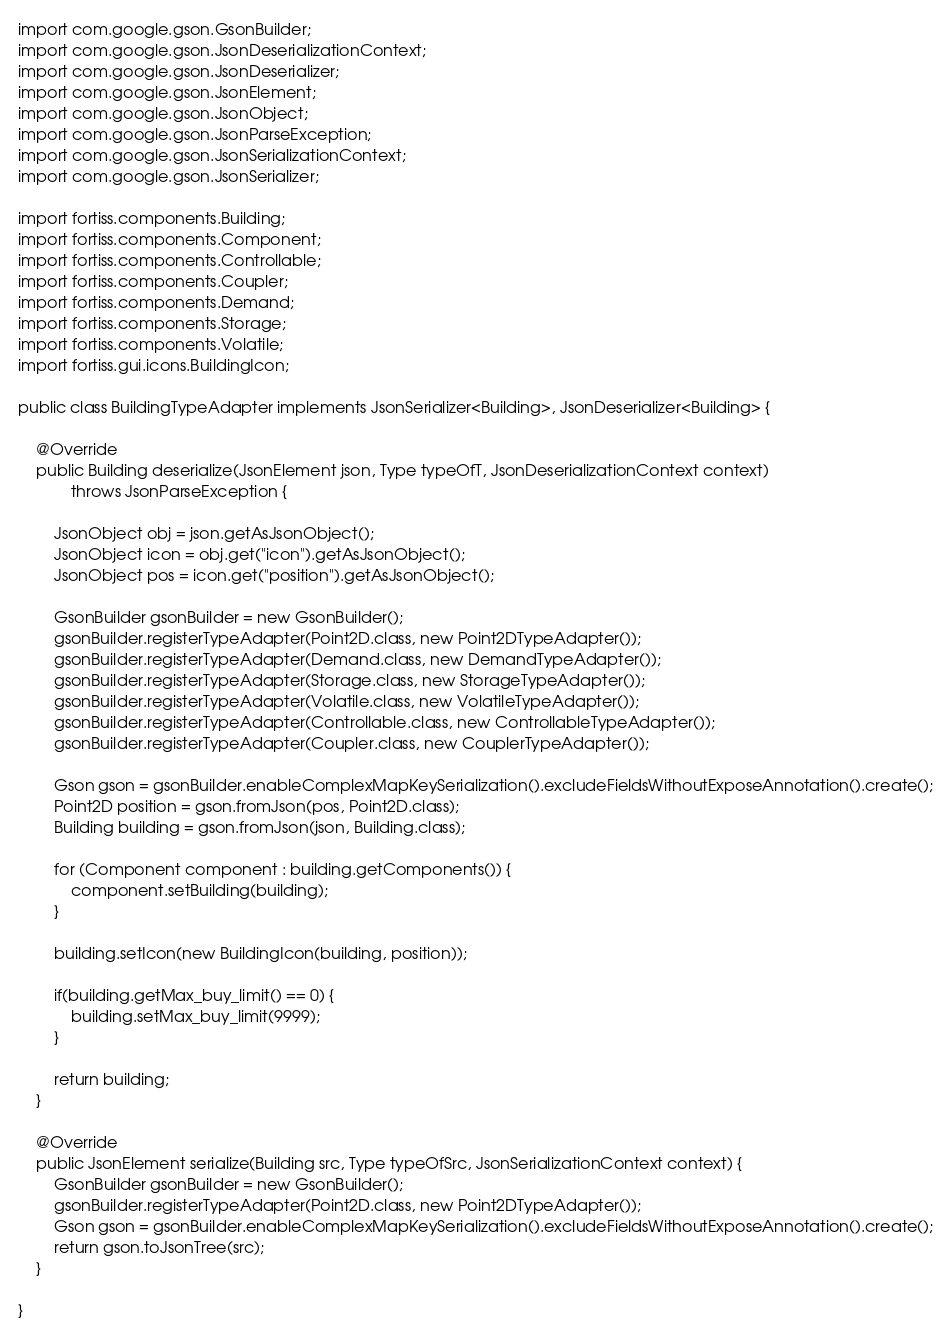<code> <loc_0><loc_0><loc_500><loc_500><_Java_>import com.google.gson.GsonBuilder;
import com.google.gson.JsonDeserializationContext;
import com.google.gson.JsonDeserializer;
import com.google.gson.JsonElement;
import com.google.gson.JsonObject;
import com.google.gson.JsonParseException;
import com.google.gson.JsonSerializationContext;
import com.google.gson.JsonSerializer;

import fortiss.components.Building;
import fortiss.components.Component;
import fortiss.components.Controllable;
import fortiss.components.Coupler;
import fortiss.components.Demand;
import fortiss.components.Storage;
import fortiss.components.Volatile;
import fortiss.gui.icons.BuildingIcon;

public class BuildingTypeAdapter implements JsonSerializer<Building>, JsonDeserializer<Building> {

	@Override
	public Building deserialize(JsonElement json, Type typeOfT, JsonDeserializationContext context)
			throws JsonParseException {

		JsonObject obj = json.getAsJsonObject();
		JsonObject icon = obj.get("icon").getAsJsonObject();
		JsonObject pos = icon.get("position").getAsJsonObject();

		GsonBuilder gsonBuilder = new GsonBuilder();
		gsonBuilder.registerTypeAdapter(Point2D.class, new Point2DTypeAdapter());
		gsonBuilder.registerTypeAdapter(Demand.class, new DemandTypeAdapter());
		gsonBuilder.registerTypeAdapter(Storage.class, new StorageTypeAdapter());
		gsonBuilder.registerTypeAdapter(Volatile.class, new VolatileTypeAdapter());
		gsonBuilder.registerTypeAdapter(Controllable.class, new ControllableTypeAdapter());
		gsonBuilder.registerTypeAdapter(Coupler.class, new CouplerTypeAdapter());

		Gson gson = gsonBuilder.enableComplexMapKeySerialization().excludeFieldsWithoutExposeAnnotation().create();
		Point2D position = gson.fromJson(pos, Point2D.class);
		Building building = gson.fromJson(json, Building.class);

		for (Component component : building.getComponents()) {
			component.setBuilding(building);
		}

		building.setIcon(new BuildingIcon(building, position));
		
		if(building.getMax_buy_limit() == 0) {
			building.setMax_buy_limit(9999);
		}

		return building;
	}

	@Override
	public JsonElement serialize(Building src, Type typeOfSrc, JsonSerializationContext context) {
		GsonBuilder gsonBuilder = new GsonBuilder();
		gsonBuilder.registerTypeAdapter(Point2D.class, new Point2DTypeAdapter());
		Gson gson = gsonBuilder.enableComplexMapKeySerialization().excludeFieldsWithoutExposeAnnotation().create();
		return gson.toJsonTree(src);
	}

}
</code> 